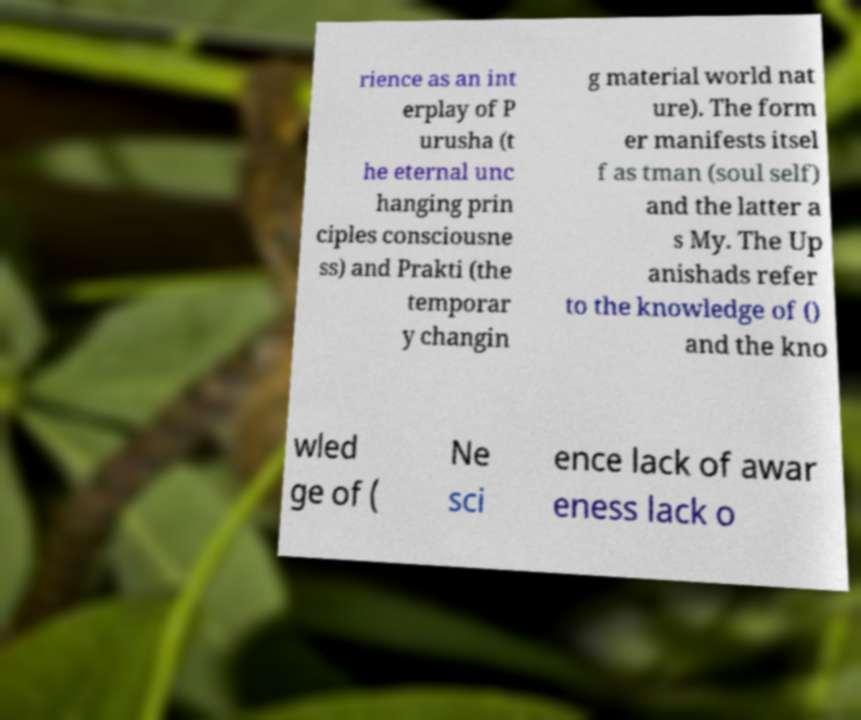What messages or text are displayed in this image? I need them in a readable, typed format. rience as an int erplay of P urusha (t he eternal unc hanging prin ciples consciousne ss) and Prakti (the temporar y changin g material world nat ure). The form er manifests itsel f as tman (soul self) and the latter a s My. The Up anishads refer to the knowledge of () and the kno wled ge of ( Ne sci ence lack of awar eness lack o 